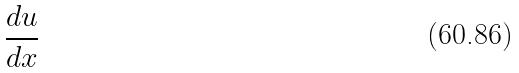Convert formula to latex. <formula><loc_0><loc_0><loc_500><loc_500>\frac { d u } { d x }</formula> 